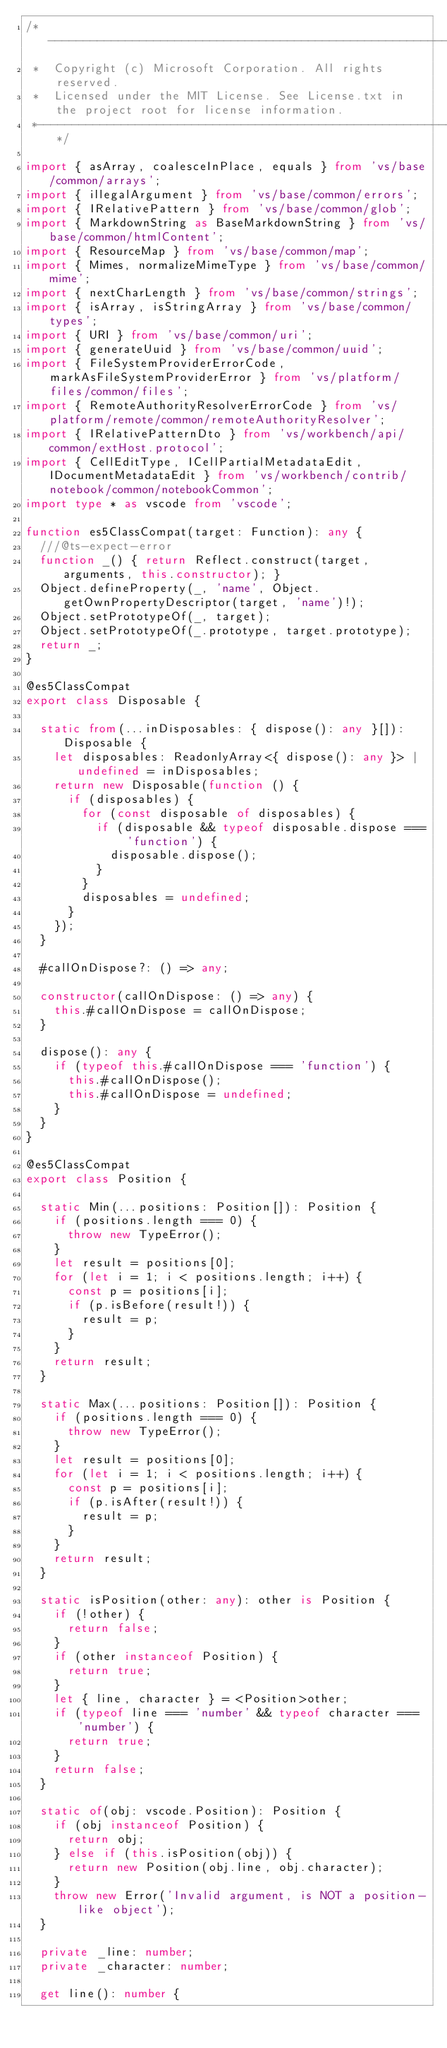Convert code to text. <code><loc_0><loc_0><loc_500><loc_500><_TypeScript_>/*---------------------------------------------------------------------------------------------
 *  Copyright (c) Microsoft Corporation. All rights reserved.
 *  Licensed under the MIT License. See License.txt in the project root for license information.
 *--------------------------------------------------------------------------------------------*/

import { asArray, coalesceInPlace, equals } from 'vs/base/common/arrays';
import { illegalArgument } from 'vs/base/common/errors';
import { IRelativePattern } from 'vs/base/common/glob';
import { MarkdownString as BaseMarkdownString } from 'vs/base/common/htmlContent';
import { ResourceMap } from 'vs/base/common/map';
import { Mimes, normalizeMimeType } from 'vs/base/common/mime';
import { nextCharLength } from 'vs/base/common/strings';
import { isArray, isStringArray } from 'vs/base/common/types';
import { URI } from 'vs/base/common/uri';
import { generateUuid } from 'vs/base/common/uuid';
import { FileSystemProviderErrorCode, markAsFileSystemProviderError } from 'vs/platform/files/common/files';
import { RemoteAuthorityResolverErrorCode } from 'vs/platform/remote/common/remoteAuthorityResolver';
import { IRelativePatternDto } from 'vs/workbench/api/common/extHost.protocol';
import { CellEditType, ICellPartialMetadataEdit, IDocumentMetadataEdit } from 'vs/workbench/contrib/notebook/common/notebookCommon';
import type * as vscode from 'vscode';

function es5ClassCompat(target: Function): any {
	///@ts-expect-error
	function _() { return Reflect.construct(target, arguments, this.constructor); }
	Object.defineProperty(_, 'name', Object.getOwnPropertyDescriptor(target, 'name')!);
	Object.setPrototypeOf(_, target);
	Object.setPrototypeOf(_.prototype, target.prototype);
	return _;
}

@es5ClassCompat
export class Disposable {

	static from(...inDisposables: { dispose(): any }[]): Disposable {
		let disposables: ReadonlyArray<{ dispose(): any }> | undefined = inDisposables;
		return new Disposable(function () {
			if (disposables) {
				for (const disposable of disposables) {
					if (disposable && typeof disposable.dispose === 'function') {
						disposable.dispose();
					}
				}
				disposables = undefined;
			}
		});
	}

	#callOnDispose?: () => any;

	constructor(callOnDispose: () => any) {
		this.#callOnDispose = callOnDispose;
	}

	dispose(): any {
		if (typeof this.#callOnDispose === 'function') {
			this.#callOnDispose();
			this.#callOnDispose = undefined;
		}
	}
}

@es5ClassCompat
export class Position {

	static Min(...positions: Position[]): Position {
		if (positions.length === 0) {
			throw new TypeError();
		}
		let result = positions[0];
		for (let i = 1; i < positions.length; i++) {
			const p = positions[i];
			if (p.isBefore(result!)) {
				result = p;
			}
		}
		return result;
	}

	static Max(...positions: Position[]): Position {
		if (positions.length === 0) {
			throw new TypeError();
		}
		let result = positions[0];
		for (let i = 1; i < positions.length; i++) {
			const p = positions[i];
			if (p.isAfter(result!)) {
				result = p;
			}
		}
		return result;
	}

	static isPosition(other: any): other is Position {
		if (!other) {
			return false;
		}
		if (other instanceof Position) {
			return true;
		}
		let { line, character } = <Position>other;
		if (typeof line === 'number' && typeof character === 'number') {
			return true;
		}
		return false;
	}

	static of(obj: vscode.Position): Position {
		if (obj instanceof Position) {
			return obj;
		} else if (this.isPosition(obj)) {
			return new Position(obj.line, obj.character);
		}
		throw new Error('Invalid argument, is NOT a position-like object');
	}

	private _line: number;
	private _character: number;

	get line(): number {</code> 